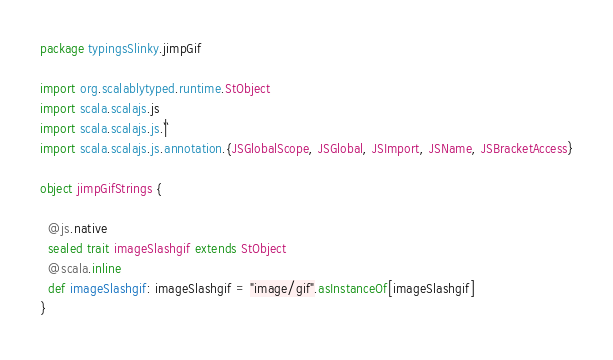<code> <loc_0><loc_0><loc_500><loc_500><_Scala_>package typingsSlinky.jimpGif

import org.scalablytyped.runtime.StObject
import scala.scalajs.js
import scala.scalajs.js.`|`
import scala.scalajs.js.annotation.{JSGlobalScope, JSGlobal, JSImport, JSName, JSBracketAccess}

object jimpGifStrings {
  
  @js.native
  sealed trait imageSlashgif extends StObject
  @scala.inline
  def imageSlashgif: imageSlashgif = "image/gif".asInstanceOf[imageSlashgif]
}
</code> 